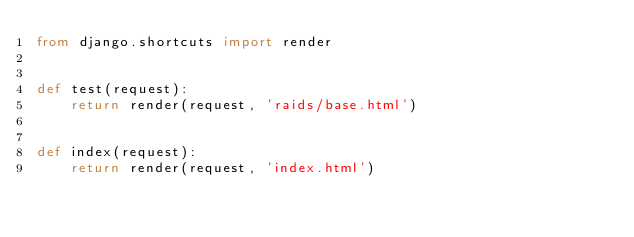Convert code to text. <code><loc_0><loc_0><loc_500><loc_500><_Python_>from django.shortcuts import render


def test(request):
    return render(request, 'raids/base.html')


def index(request):
    return render(request, 'index.html')
</code> 